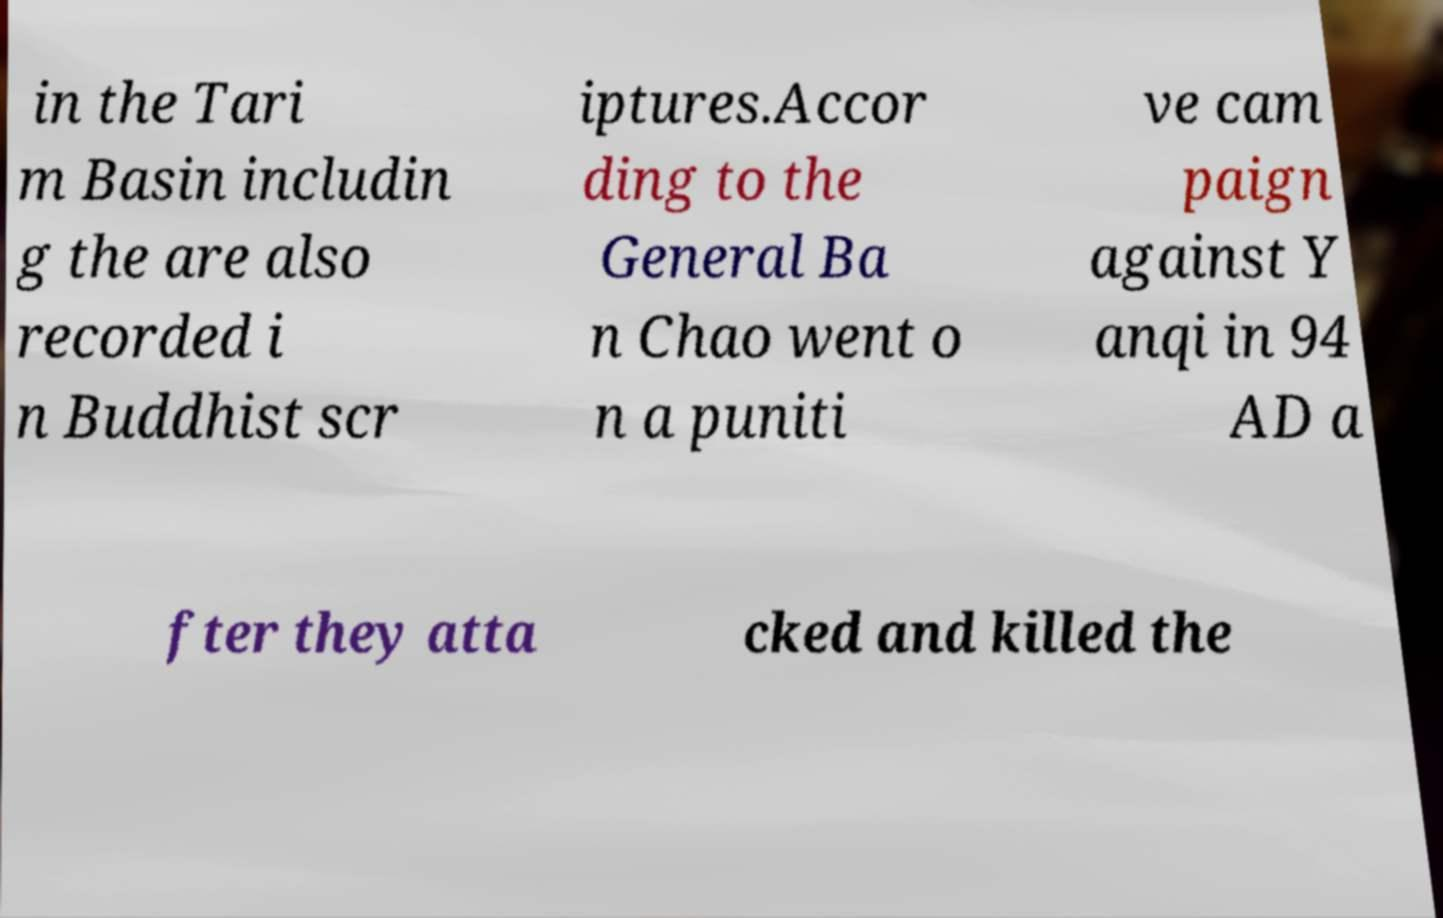For documentation purposes, I need the text within this image transcribed. Could you provide that? in the Tari m Basin includin g the are also recorded i n Buddhist scr iptures.Accor ding to the General Ba n Chao went o n a puniti ve cam paign against Y anqi in 94 AD a fter they atta cked and killed the 